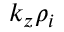Convert formula to latex. <formula><loc_0><loc_0><loc_500><loc_500>k _ { z } \rho _ { i }</formula> 